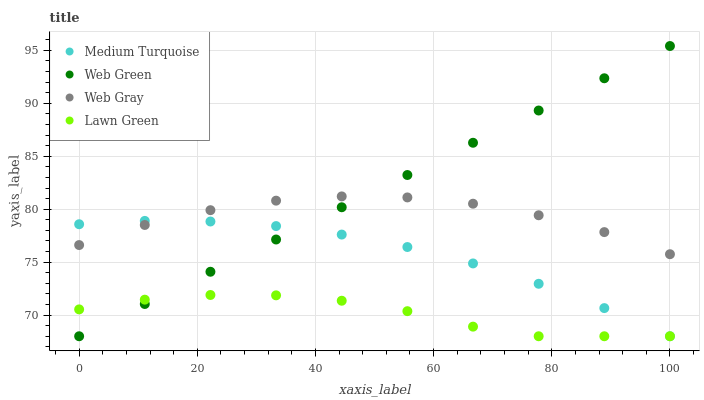Does Lawn Green have the minimum area under the curve?
Answer yes or no. Yes. Does Web Green have the maximum area under the curve?
Answer yes or no. Yes. Does Web Gray have the minimum area under the curve?
Answer yes or no. No. Does Web Gray have the maximum area under the curve?
Answer yes or no. No. Is Web Green the smoothest?
Answer yes or no. Yes. Is Web Gray the roughest?
Answer yes or no. Yes. Is Web Gray the smoothest?
Answer yes or no. No. Is Web Green the roughest?
Answer yes or no. No. Does Lawn Green have the lowest value?
Answer yes or no. Yes. Does Web Gray have the lowest value?
Answer yes or no. No. Does Web Green have the highest value?
Answer yes or no. Yes. Does Web Gray have the highest value?
Answer yes or no. No. Is Lawn Green less than Web Gray?
Answer yes or no. Yes. Is Web Gray greater than Lawn Green?
Answer yes or no. Yes. Does Medium Turquoise intersect Web Gray?
Answer yes or no. Yes. Is Medium Turquoise less than Web Gray?
Answer yes or no. No. Is Medium Turquoise greater than Web Gray?
Answer yes or no. No. Does Lawn Green intersect Web Gray?
Answer yes or no. No. 